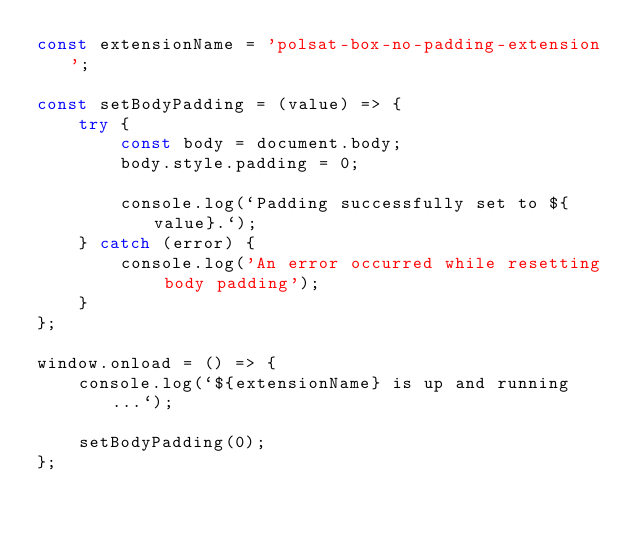<code> <loc_0><loc_0><loc_500><loc_500><_JavaScript_>const extensionName = 'polsat-box-no-padding-extension';

const setBodyPadding = (value) => {
    try {
        const body = document.body;
        body.style.padding = 0;

        console.log(`Padding successfully set to ${value}.`);
    } catch (error) {
        console.log('An error occurred while resetting body padding');
    }
};

window.onload = () => {
    console.log(`${extensionName} is up and running...`);

    setBodyPadding(0);
};
</code> 